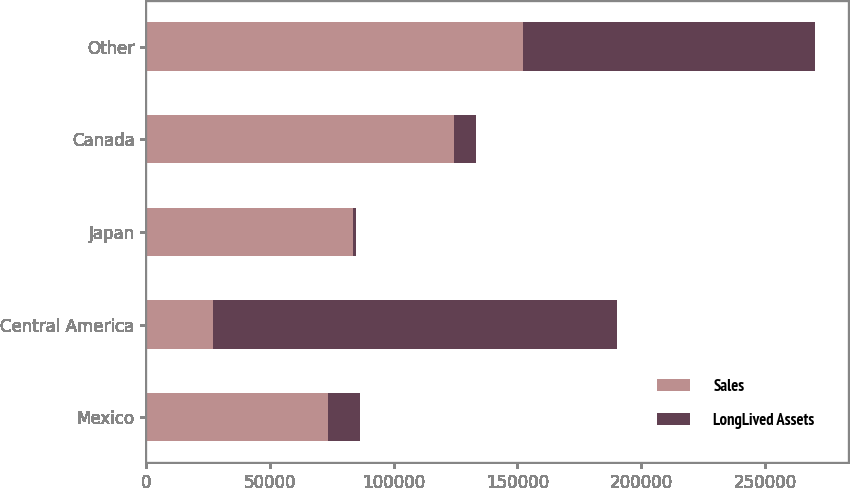<chart> <loc_0><loc_0><loc_500><loc_500><stacked_bar_chart><ecel><fcel>Mexico<fcel>Central America<fcel>Japan<fcel>Canada<fcel>Other<nl><fcel>Sales<fcel>73427<fcel>26851<fcel>83606<fcel>124500<fcel>152415<nl><fcel>LongLived Assets<fcel>12844<fcel>163542<fcel>1116<fcel>8902<fcel>117629<nl></chart> 